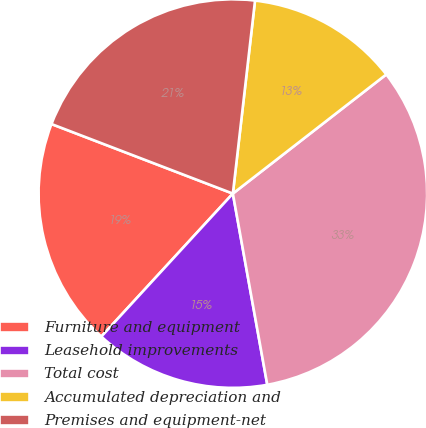Convert chart. <chart><loc_0><loc_0><loc_500><loc_500><pie_chart><fcel>Furniture and equipment<fcel>Leasehold improvements<fcel>Total cost<fcel>Accumulated depreciation and<fcel>Premises and equipment-net<nl><fcel>18.99%<fcel>14.67%<fcel>32.67%<fcel>12.67%<fcel>20.99%<nl></chart> 